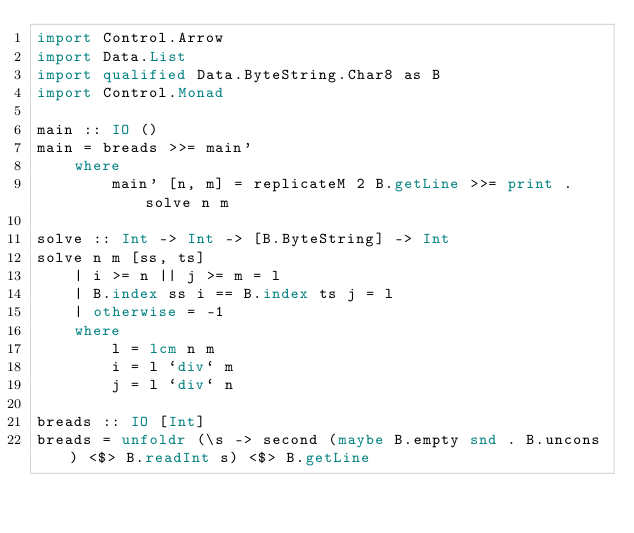Convert code to text. <code><loc_0><loc_0><loc_500><loc_500><_Haskell_>import Control.Arrow
import Data.List
import qualified Data.ByteString.Char8 as B
import Control.Monad

main :: IO ()
main = breads >>= main'
    where
        main' [n, m] = replicateM 2 B.getLine >>= print . solve n m 

solve :: Int -> Int -> [B.ByteString] -> Int
solve n m [ss, ts]
    | i >= n || j >= m = l
    | B.index ss i == B.index ts j = l
    | otherwise = -1
    where
        l = lcm n m 
        i = l `div` m
        j = l `div` n 

breads :: IO [Int]
breads = unfoldr (\s -> second (maybe B.empty snd . B.uncons) <$> B.readInt s) <$> B.getLine</code> 